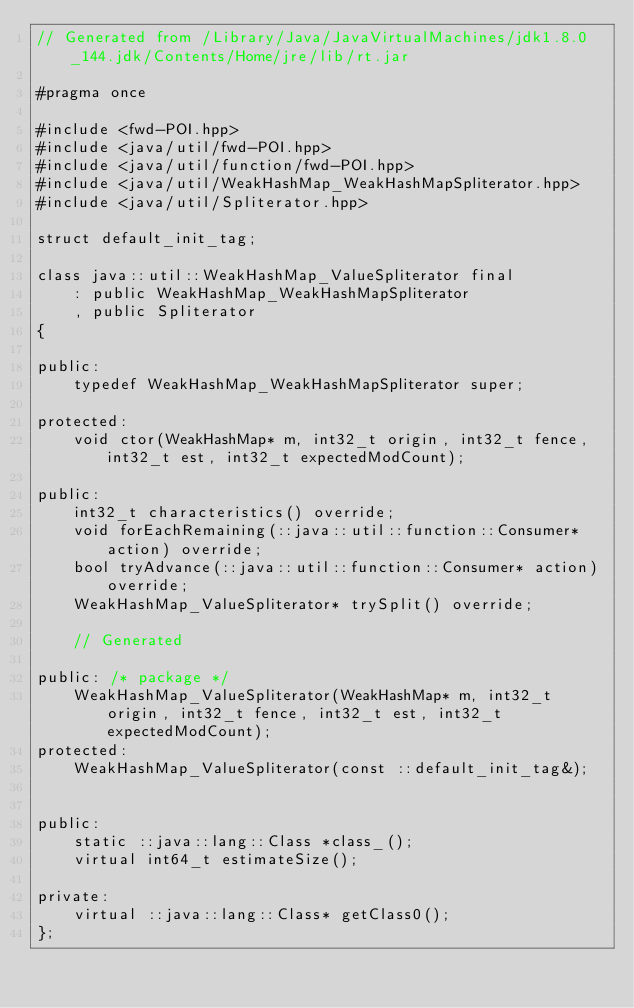Convert code to text. <code><loc_0><loc_0><loc_500><loc_500><_C++_>// Generated from /Library/Java/JavaVirtualMachines/jdk1.8.0_144.jdk/Contents/Home/jre/lib/rt.jar

#pragma once

#include <fwd-POI.hpp>
#include <java/util/fwd-POI.hpp>
#include <java/util/function/fwd-POI.hpp>
#include <java/util/WeakHashMap_WeakHashMapSpliterator.hpp>
#include <java/util/Spliterator.hpp>

struct default_init_tag;

class java::util::WeakHashMap_ValueSpliterator final
    : public WeakHashMap_WeakHashMapSpliterator
    , public Spliterator
{

public:
    typedef WeakHashMap_WeakHashMapSpliterator super;

protected:
    void ctor(WeakHashMap* m, int32_t origin, int32_t fence, int32_t est, int32_t expectedModCount);

public:
    int32_t characteristics() override;
    void forEachRemaining(::java::util::function::Consumer* action) override;
    bool tryAdvance(::java::util::function::Consumer* action) override;
    WeakHashMap_ValueSpliterator* trySplit() override;

    // Generated

public: /* package */
    WeakHashMap_ValueSpliterator(WeakHashMap* m, int32_t origin, int32_t fence, int32_t est, int32_t expectedModCount);
protected:
    WeakHashMap_ValueSpliterator(const ::default_init_tag&);


public:
    static ::java::lang::Class *class_();
    virtual int64_t estimateSize();

private:
    virtual ::java::lang::Class* getClass0();
};
</code> 